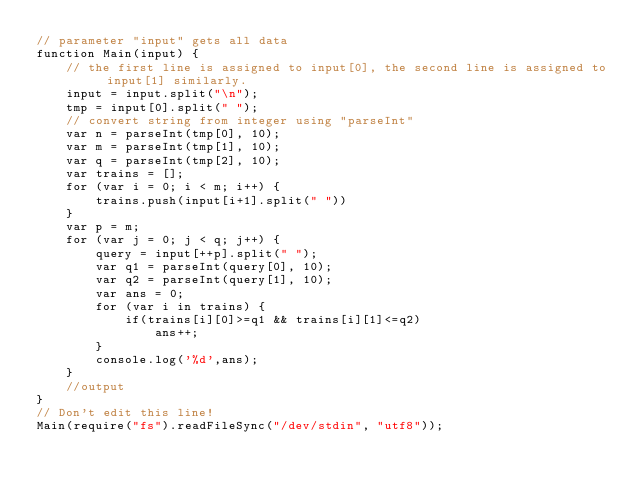<code> <loc_0><loc_0><loc_500><loc_500><_JavaScript_>// parameter "input" gets all data
function Main(input) {
	// the first line is assigned to input[0], the second line is assigned to input[1] similarly.
	input = input.split("\n");
	tmp = input[0].split(" ");
	// convert string from integer using "parseInt"
	var n = parseInt(tmp[0], 10);
	var m = parseInt(tmp[1], 10);
	var q = parseInt(tmp[2], 10);
	var trains = [];
	for (var i = 0; i < m; i++) {
		trains.push(input[i+1].split(" "))
	}
	var p = m;
	for (var j = 0; j < q; j++) {
		query = input[++p].split(" ");
		var q1 = parseInt(query[0], 10);
		var q2 = parseInt(query[1], 10);
		var ans = 0;
		for (var i in trains) {
			if(trains[i][0]>=q1 && trains[i][1]<=q2)
				ans++;
		}
		console.log('%d',ans);
	}
	//output
}
// Don't edit this line!
Main(require("fs").readFileSync("/dev/stdin", "utf8"));</code> 